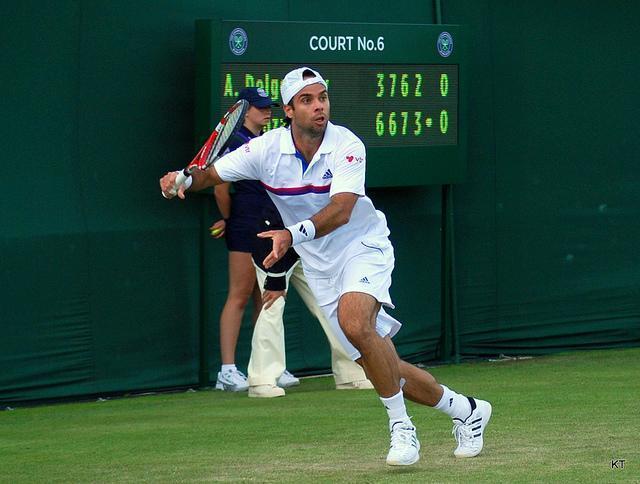How many people can you see?
Give a very brief answer. 2. 